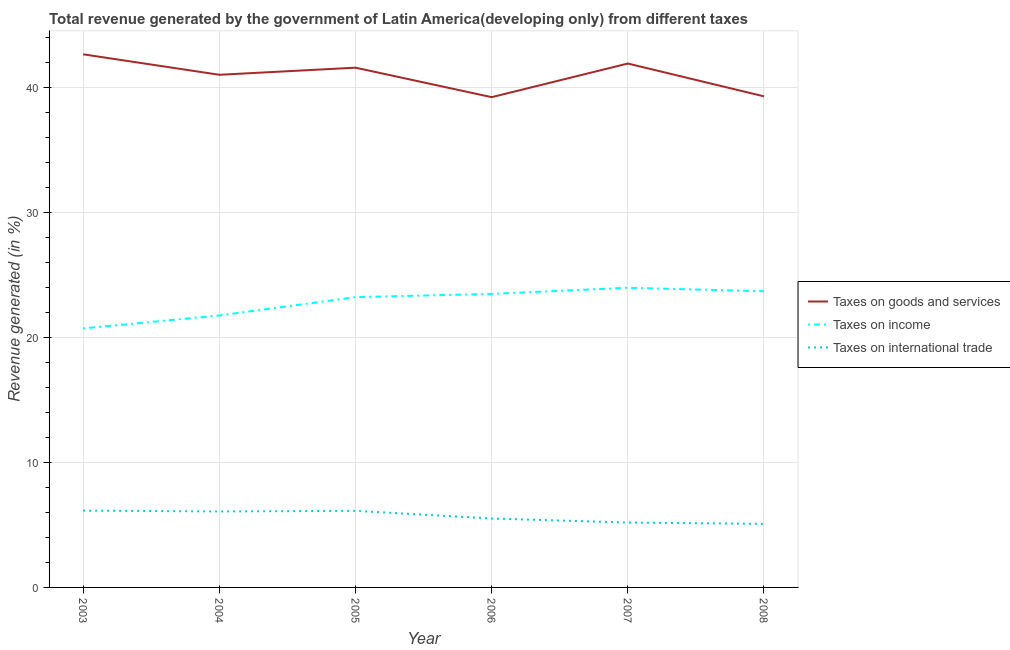How many different coloured lines are there?
Your response must be concise. 3. Does the line corresponding to percentage of revenue generated by tax on international trade intersect with the line corresponding to percentage of revenue generated by taxes on income?
Ensure brevity in your answer.  No. Is the number of lines equal to the number of legend labels?
Keep it short and to the point. Yes. What is the percentage of revenue generated by taxes on goods and services in 2004?
Make the answer very short. 40.99. Across all years, what is the maximum percentage of revenue generated by taxes on goods and services?
Offer a terse response. 42.63. Across all years, what is the minimum percentage of revenue generated by taxes on income?
Offer a terse response. 20.71. In which year was the percentage of revenue generated by taxes on income maximum?
Your response must be concise. 2007. What is the total percentage of revenue generated by tax on international trade in the graph?
Make the answer very short. 34.13. What is the difference between the percentage of revenue generated by taxes on income in 2004 and that in 2005?
Your answer should be compact. -1.46. What is the difference between the percentage of revenue generated by tax on international trade in 2008 and the percentage of revenue generated by taxes on income in 2003?
Offer a terse response. -15.63. What is the average percentage of revenue generated by taxes on income per year?
Provide a short and direct response. 22.8. In the year 2008, what is the difference between the percentage of revenue generated by tax on international trade and percentage of revenue generated by taxes on income?
Make the answer very short. -18.6. What is the ratio of the percentage of revenue generated by taxes on income in 2004 to that in 2007?
Your answer should be compact. 0.91. What is the difference between the highest and the second highest percentage of revenue generated by taxes on income?
Your response must be concise. 0.28. What is the difference between the highest and the lowest percentage of revenue generated by tax on international trade?
Keep it short and to the point. 1.06. Is the percentage of revenue generated by tax on international trade strictly less than the percentage of revenue generated by taxes on goods and services over the years?
Offer a very short reply. Yes. How many lines are there?
Provide a succinct answer. 3. How many years are there in the graph?
Your answer should be compact. 6. What is the difference between two consecutive major ticks on the Y-axis?
Keep it short and to the point. 10. Are the values on the major ticks of Y-axis written in scientific E-notation?
Give a very brief answer. No. Does the graph contain grids?
Your response must be concise. Yes. How are the legend labels stacked?
Give a very brief answer. Vertical. What is the title of the graph?
Provide a succinct answer. Total revenue generated by the government of Latin America(developing only) from different taxes. What is the label or title of the X-axis?
Provide a succinct answer. Year. What is the label or title of the Y-axis?
Offer a terse response. Revenue generated (in %). What is the Revenue generated (in %) in Taxes on goods and services in 2003?
Offer a very short reply. 42.63. What is the Revenue generated (in %) of Taxes on income in 2003?
Provide a succinct answer. 20.71. What is the Revenue generated (in %) in Taxes on international trade in 2003?
Keep it short and to the point. 6.14. What is the Revenue generated (in %) in Taxes on goods and services in 2004?
Provide a succinct answer. 40.99. What is the Revenue generated (in %) of Taxes on income in 2004?
Give a very brief answer. 21.75. What is the Revenue generated (in %) in Taxes on international trade in 2004?
Your answer should be very brief. 6.08. What is the Revenue generated (in %) of Taxes on goods and services in 2005?
Give a very brief answer. 41.56. What is the Revenue generated (in %) of Taxes on income in 2005?
Provide a short and direct response. 23.21. What is the Revenue generated (in %) of Taxes on international trade in 2005?
Make the answer very short. 6.12. What is the Revenue generated (in %) of Taxes on goods and services in 2006?
Your answer should be compact. 39.2. What is the Revenue generated (in %) of Taxes on income in 2006?
Your answer should be compact. 23.47. What is the Revenue generated (in %) in Taxes on international trade in 2006?
Your answer should be compact. 5.51. What is the Revenue generated (in %) of Taxes on goods and services in 2007?
Give a very brief answer. 41.89. What is the Revenue generated (in %) in Taxes on income in 2007?
Your answer should be compact. 23.96. What is the Revenue generated (in %) in Taxes on international trade in 2007?
Ensure brevity in your answer.  5.19. What is the Revenue generated (in %) of Taxes on goods and services in 2008?
Keep it short and to the point. 39.27. What is the Revenue generated (in %) in Taxes on income in 2008?
Your answer should be compact. 23.68. What is the Revenue generated (in %) of Taxes on international trade in 2008?
Offer a terse response. 5.08. Across all years, what is the maximum Revenue generated (in %) of Taxes on goods and services?
Offer a terse response. 42.63. Across all years, what is the maximum Revenue generated (in %) in Taxes on income?
Your answer should be very brief. 23.96. Across all years, what is the maximum Revenue generated (in %) of Taxes on international trade?
Make the answer very short. 6.14. Across all years, what is the minimum Revenue generated (in %) of Taxes on goods and services?
Keep it short and to the point. 39.2. Across all years, what is the minimum Revenue generated (in %) in Taxes on income?
Provide a short and direct response. 20.71. Across all years, what is the minimum Revenue generated (in %) of Taxes on international trade?
Keep it short and to the point. 5.08. What is the total Revenue generated (in %) in Taxes on goods and services in the graph?
Your response must be concise. 245.56. What is the total Revenue generated (in %) of Taxes on income in the graph?
Keep it short and to the point. 136.79. What is the total Revenue generated (in %) of Taxes on international trade in the graph?
Provide a succinct answer. 34.13. What is the difference between the Revenue generated (in %) in Taxes on goods and services in 2003 and that in 2004?
Give a very brief answer. 1.64. What is the difference between the Revenue generated (in %) of Taxes on income in 2003 and that in 2004?
Your response must be concise. -1.03. What is the difference between the Revenue generated (in %) in Taxes on international trade in 2003 and that in 2004?
Ensure brevity in your answer.  0.07. What is the difference between the Revenue generated (in %) of Taxes on goods and services in 2003 and that in 2005?
Offer a terse response. 1.07. What is the difference between the Revenue generated (in %) in Taxes on income in 2003 and that in 2005?
Make the answer very short. -2.5. What is the difference between the Revenue generated (in %) in Taxes on international trade in 2003 and that in 2005?
Provide a short and direct response. 0.02. What is the difference between the Revenue generated (in %) of Taxes on goods and services in 2003 and that in 2006?
Offer a terse response. 3.43. What is the difference between the Revenue generated (in %) in Taxes on income in 2003 and that in 2006?
Your answer should be compact. -2.76. What is the difference between the Revenue generated (in %) in Taxes on international trade in 2003 and that in 2006?
Offer a terse response. 0.63. What is the difference between the Revenue generated (in %) in Taxes on goods and services in 2003 and that in 2007?
Offer a terse response. 0.74. What is the difference between the Revenue generated (in %) of Taxes on income in 2003 and that in 2007?
Provide a short and direct response. -3.25. What is the difference between the Revenue generated (in %) in Taxes on international trade in 2003 and that in 2007?
Ensure brevity in your answer.  0.95. What is the difference between the Revenue generated (in %) of Taxes on goods and services in 2003 and that in 2008?
Your answer should be compact. 3.36. What is the difference between the Revenue generated (in %) in Taxes on income in 2003 and that in 2008?
Give a very brief answer. -2.97. What is the difference between the Revenue generated (in %) of Taxes on international trade in 2003 and that in 2008?
Give a very brief answer. 1.06. What is the difference between the Revenue generated (in %) of Taxes on goods and services in 2004 and that in 2005?
Your response must be concise. -0.57. What is the difference between the Revenue generated (in %) of Taxes on income in 2004 and that in 2005?
Give a very brief answer. -1.46. What is the difference between the Revenue generated (in %) of Taxes on international trade in 2004 and that in 2005?
Ensure brevity in your answer.  -0.05. What is the difference between the Revenue generated (in %) in Taxes on goods and services in 2004 and that in 2006?
Keep it short and to the point. 1.79. What is the difference between the Revenue generated (in %) of Taxes on income in 2004 and that in 2006?
Provide a succinct answer. -1.73. What is the difference between the Revenue generated (in %) of Taxes on international trade in 2004 and that in 2006?
Your answer should be compact. 0.56. What is the difference between the Revenue generated (in %) of Taxes on goods and services in 2004 and that in 2007?
Make the answer very short. -0.9. What is the difference between the Revenue generated (in %) in Taxes on income in 2004 and that in 2007?
Give a very brief answer. -2.22. What is the difference between the Revenue generated (in %) in Taxes on international trade in 2004 and that in 2007?
Ensure brevity in your answer.  0.89. What is the difference between the Revenue generated (in %) in Taxes on goods and services in 2004 and that in 2008?
Your answer should be compact. 1.72. What is the difference between the Revenue generated (in %) of Taxes on income in 2004 and that in 2008?
Provide a succinct answer. -1.94. What is the difference between the Revenue generated (in %) in Taxes on international trade in 2004 and that in 2008?
Make the answer very short. 0.99. What is the difference between the Revenue generated (in %) of Taxes on goods and services in 2005 and that in 2006?
Ensure brevity in your answer.  2.36. What is the difference between the Revenue generated (in %) in Taxes on income in 2005 and that in 2006?
Ensure brevity in your answer.  -0.26. What is the difference between the Revenue generated (in %) in Taxes on international trade in 2005 and that in 2006?
Provide a succinct answer. 0.61. What is the difference between the Revenue generated (in %) in Taxes on goods and services in 2005 and that in 2007?
Offer a very short reply. -0.33. What is the difference between the Revenue generated (in %) in Taxes on income in 2005 and that in 2007?
Your answer should be very brief. -0.75. What is the difference between the Revenue generated (in %) of Taxes on international trade in 2005 and that in 2007?
Provide a succinct answer. 0.94. What is the difference between the Revenue generated (in %) of Taxes on goods and services in 2005 and that in 2008?
Keep it short and to the point. 2.29. What is the difference between the Revenue generated (in %) in Taxes on income in 2005 and that in 2008?
Make the answer very short. -0.47. What is the difference between the Revenue generated (in %) in Taxes on international trade in 2005 and that in 2008?
Your response must be concise. 1.04. What is the difference between the Revenue generated (in %) in Taxes on goods and services in 2006 and that in 2007?
Offer a very short reply. -2.69. What is the difference between the Revenue generated (in %) in Taxes on income in 2006 and that in 2007?
Your answer should be very brief. -0.49. What is the difference between the Revenue generated (in %) in Taxes on international trade in 2006 and that in 2007?
Make the answer very short. 0.32. What is the difference between the Revenue generated (in %) in Taxes on goods and services in 2006 and that in 2008?
Keep it short and to the point. -0.07. What is the difference between the Revenue generated (in %) in Taxes on income in 2006 and that in 2008?
Provide a succinct answer. -0.21. What is the difference between the Revenue generated (in %) of Taxes on international trade in 2006 and that in 2008?
Keep it short and to the point. 0.43. What is the difference between the Revenue generated (in %) in Taxes on goods and services in 2007 and that in 2008?
Your response must be concise. 2.62. What is the difference between the Revenue generated (in %) in Taxes on income in 2007 and that in 2008?
Offer a very short reply. 0.28. What is the difference between the Revenue generated (in %) in Taxes on international trade in 2007 and that in 2008?
Give a very brief answer. 0.11. What is the difference between the Revenue generated (in %) in Taxes on goods and services in 2003 and the Revenue generated (in %) in Taxes on income in 2004?
Keep it short and to the point. 20.89. What is the difference between the Revenue generated (in %) in Taxes on goods and services in 2003 and the Revenue generated (in %) in Taxes on international trade in 2004?
Your answer should be compact. 36.56. What is the difference between the Revenue generated (in %) in Taxes on income in 2003 and the Revenue generated (in %) in Taxes on international trade in 2004?
Keep it short and to the point. 14.64. What is the difference between the Revenue generated (in %) of Taxes on goods and services in 2003 and the Revenue generated (in %) of Taxes on income in 2005?
Give a very brief answer. 19.42. What is the difference between the Revenue generated (in %) in Taxes on goods and services in 2003 and the Revenue generated (in %) in Taxes on international trade in 2005?
Offer a terse response. 36.51. What is the difference between the Revenue generated (in %) of Taxes on income in 2003 and the Revenue generated (in %) of Taxes on international trade in 2005?
Provide a short and direct response. 14.59. What is the difference between the Revenue generated (in %) of Taxes on goods and services in 2003 and the Revenue generated (in %) of Taxes on income in 2006?
Make the answer very short. 19.16. What is the difference between the Revenue generated (in %) of Taxes on goods and services in 2003 and the Revenue generated (in %) of Taxes on international trade in 2006?
Your answer should be compact. 37.12. What is the difference between the Revenue generated (in %) in Taxes on income in 2003 and the Revenue generated (in %) in Taxes on international trade in 2006?
Provide a succinct answer. 15.2. What is the difference between the Revenue generated (in %) of Taxes on goods and services in 2003 and the Revenue generated (in %) of Taxes on income in 2007?
Your answer should be very brief. 18.67. What is the difference between the Revenue generated (in %) of Taxes on goods and services in 2003 and the Revenue generated (in %) of Taxes on international trade in 2007?
Provide a succinct answer. 37.44. What is the difference between the Revenue generated (in %) of Taxes on income in 2003 and the Revenue generated (in %) of Taxes on international trade in 2007?
Make the answer very short. 15.52. What is the difference between the Revenue generated (in %) of Taxes on goods and services in 2003 and the Revenue generated (in %) of Taxes on income in 2008?
Offer a very short reply. 18.95. What is the difference between the Revenue generated (in %) in Taxes on goods and services in 2003 and the Revenue generated (in %) in Taxes on international trade in 2008?
Ensure brevity in your answer.  37.55. What is the difference between the Revenue generated (in %) in Taxes on income in 2003 and the Revenue generated (in %) in Taxes on international trade in 2008?
Ensure brevity in your answer.  15.63. What is the difference between the Revenue generated (in %) of Taxes on goods and services in 2004 and the Revenue generated (in %) of Taxes on income in 2005?
Your answer should be compact. 17.78. What is the difference between the Revenue generated (in %) of Taxes on goods and services in 2004 and the Revenue generated (in %) of Taxes on international trade in 2005?
Your response must be concise. 34.87. What is the difference between the Revenue generated (in %) of Taxes on income in 2004 and the Revenue generated (in %) of Taxes on international trade in 2005?
Make the answer very short. 15.62. What is the difference between the Revenue generated (in %) of Taxes on goods and services in 2004 and the Revenue generated (in %) of Taxes on income in 2006?
Keep it short and to the point. 17.52. What is the difference between the Revenue generated (in %) in Taxes on goods and services in 2004 and the Revenue generated (in %) in Taxes on international trade in 2006?
Your response must be concise. 35.48. What is the difference between the Revenue generated (in %) in Taxes on income in 2004 and the Revenue generated (in %) in Taxes on international trade in 2006?
Keep it short and to the point. 16.23. What is the difference between the Revenue generated (in %) in Taxes on goods and services in 2004 and the Revenue generated (in %) in Taxes on income in 2007?
Your answer should be very brief. 17.03. What is the difference between the Revenue generated (in %) in Taxes on goods and services in 2004 and the Revenue generated (in %) in Taxes on international trade in 2007?
Your response must be concise. 35.81. What is the difference between the Revenue generated (in %) of Taxes on income in 2004 and the Revenue generated (in %) of Taxes on international trade in 2007?
Make the answer very short. 16.56. What is the difference between the Revenue generated (in %) in Taxes on goods and services in 2004 and the Revenue generated (in %) in Taxes on income in 2008?
Provide a short and direct response. 17.31. What is the difference between the Revenue generated (in %) in Taxes on goods and services in 2004 and the Revenue generated (in %) in Taxes on international trade in 2008?
Offer a terse response. 35.91. What is the difference between the Revenue generated (in %) in Taxes on income in 2004 and the Revenue generated (in %) in Taxes on international trade in 2008?
Provide a succinct answer. 16.67. What is the difference between the Revenue generated (in %) of Taxes on goods and services in 2005 and the Revenue generated (in %) of Taxes on income in 2006?
Make the answer very short. 18.09. What is the difference between the Revenue generated (in %) in Taxes on goods and services in 2005 and the Revenue generated (in %) in Taxes on international trade in 2006?
Ensure brevity in your answer.  36.05. What is the difference between the Revenue generated (in %) in Taxes on income in 2005 and the Revenue generated (in %) in Taxes on international trade in 2006?
Your answer should be very brief. 17.7. What is the difference between the Revenue generated (in %) in Taxes on goods and services in 2005 and the Revenue generated (in %) in Taxes on income in 2007?
Make the answer very short. 17.6. What is the difference between the Revenue generated (in %) of Taxes on goods and services in 2005 and the Revenue generated (in %) of Taxes on international trade in 2007?
Make the answer very short. 36.37. What is the difference between the Revenue generated (in %) of Taxes on income in 2005 and the Revenue generated (in %) of Taxes on international trade in 2007?
Ensure brevity in your answer.  18.02. What is the difference between the Revenue generated (in %) of Taxes on goods and services in 2005 and the Revenue generated (in %) of Taxes on income in 2008?
Your answer should be very brief. 17.88. What is the difference between the Revenue generated (in %) of Taxes on goods and services in 2005 and the Revenue generated (in %) of Taxes on international trade in 2008?
Provide a short and direct response. 36.48. What is the difference between the Revenue generated (in %) of Taxes on income in 2005 and the Revenue generated (in %) of Taxes on international trade in 2008?
Make the answer very short. 18.13. What is the difference between the Revenue generated (in %) in Taxes on goods and services in 2006 and the Revenue generated (in %) in Taxes on income in 2007?
Give a very brief answer. 15.24. What is the difference between the Revenue generated (in %) of Taxes on goods and services in 2006 and the Revenue generated (in %) of Taxes on international trade in 2007?
Provide a succinct answer. 34.02. What is the difference between the Revenue generated (in %) of Taxes on income in 2006 and the Revenue generated (in %) of Taxes on international trade in 2007?
Offer a very short reply. 18.29. What is the difference between the Revenue generated (in %) in Taxes on goods and services in 2006 and the Revenue generated (in %) in Taxes on income in 2008?
Give a very brief answer. 15.52. What is the difference between the Revenue generated (in %) in Taxes on goods and services in 2006 and the Revenue generated (in %) in Taxes on international trade in 2008?
Provide a short and direct response. 34.12. What is the difference between the Revenue generated (in %) in Taxes on income in 2006 and the Revenue generated (in %) in Taxes on international trade in 2008?
Give a very brief answer. 18.39. What is the difference between the Revenue generated (in %) of Taxes on goods and services in 2007 and the Revenue generated (in %) of Taxes on income in 2008?
Make the answer very short. 18.21. What is the difference between the Revenue generated (in %) in Taxes on goods and services in 2007 and the Revenue generated (in %) in Taxes on international trade in 2008?
Your answer should be very brief. 36.81. What is the difference between the Revenue generated (in %) in Taxes on income in 2007 and the Revenue generated (in %) in Taxes on international trade in 2008?
Offer a terse response. 18.88. What is the average Revenue generated (in %) of Taxes on goods and services per year?
Your response must be concise. 40.93. What is the average Revenue generated (in %) of Taxes on income per year?
Provide a short and direct response. 22.8. What is the average Revenue generated (in %) in Taxes on international trade per year?
Give a very brief answer. 5.69. In the year 2003, what is the difference between the Revenue generated (in %) in Taxes on goods and services and Revenue generated (in %) in Taxes on income?
Keep it short and to the point. 21.92. In the year 2003, what is the difference between the Revenue generated (in %) in Taxes on goods and services and Revenue generated (in %) in Taxes on international trade?
Keep it short and to the point. 36.49. In the year 2003, what is the difference between the Revenue generated (in %) in Taxes on income and Revenue generated (in %) in Taxes on international trade?
Keep it short and to the point. 14.57. In the year 2004, what is the difference between the Revenue generated (in %) of Taxes on goods and services and Revenue generated (in %) of Taxes on income?
Offer a very short reply. 19.25. In the year 2004, what is the difference between the Revenue generated (in %) of Taxes on goods and services and Revenue generated (in %) of Taxes on international trade?
Provide a short and direct response. 34.92. In the year 2004, what is the difference between the Revenue generated (in %) of Taxes on income and Revenue generated (in %) of Taxes on international trade?
Your response must be concise. 15.67. In the year 2005, what is the difference between the Revenue generated (in %) of Taxes on goods and services and Revenue generated (in %) of Taxes on income?
Provide a succinct answer. 18.35. In the year 2005, what is the difference between the Revenue generated (in %) in Taxes on goods and services and Revenue generated (in %) in Taxes on international trade?
Keep it short and to the point. 35.44. In the year 2005, what is the difference between the Revenue generated (in %) in Taxes on income and Revenue generated (in %) in Taxes on international trade?
Give a very brief answer. 17.09. In the year 2006, what is the difference between the Revenue generated (in %) of Taxes on goods and services and Revenue generated (in %) of Taxes on income?
Offer a very short reply. 15.73. In the year 2006, what is the difference between the Revenue generated (in %) of Taxes on goods and services and Revenue generated (in %) of Taxes on international trade?
Provide a short and direct response. 33.69. In the year 2006, what is the difference between the Revenue generated (in %) of Taxes on income and Revenue generated (in %) of Taxes on international trade?
Ensure brevity in your answer.  17.96. In the year 2007, what is the difference between the Revenue generated (in %) in Taxes on goods and services and Revenue generated (in %) in Taxes on income?
Offer a terse response. 17.93. In the year 2007, what is the difference between the Revenue generated (in %) of Taxes on goods and services and Revenue generated (in %) of Taxes on international trade?
Your answer should be very brief. 36.71. In the year 2007, what is the difference between the Revenue generated (in %) of Taxes on income and Revenue generated (in %) of Taxes on international trade?
Give a very brief answer. 18.77. In the year 2008, what is the difference between the Revenue generated (in %) in Taxes on goods and services and Revenue generated (in %) in Taxes on income?
Your answer should be compact. 15.59. In the year 2008, what is the difference between the Revenue generated (in %) of Taxes on goods and services and Revenue generated (in %) of Taxes on international trade?
Provide a succinct answer. 34.19. In the year 2008, what is the difference between the Revenue generated (in %) of Taxes on income and Revenue generated (in %) of Taxes on international trade?
Give a very brief answer. 18.6. What is the ratio of the Revenue generated (in %) of Taxes on goods and services in 2003 to that in 2004?
Your answer should be very brief. 1.04. What is the ratio of the Revenue generated (in %) in Taxes on income in 2003 to that in 2004?
Ensure brevity in your answer.  0.95. What is the ratio of the Revenue generated (in %) of Taxes on international trade in 2003 to that in 2004?
Your answer should be compact. 1.01. What is the ratio of the Revenue generated (in %) in Taxes on goods and services in 2003 to that in 2005?
Provide a succinct answer. 1.03. What is the ratio of the Revenue generated (in %) in Taxes on income in 2003 to that in 2005?
Your answer should be compact. 0.89. What is the ratio of the Revenue generated (in %) of Taxes on international trade in 2003 to that in 2005?
Keep it short and to the point. 1. What is the ratio of the Revenue generated (in %) of Taxes on goods and services in 2003 to that in 2006?
Make the answer very short. 1.09. What is the ratio of the Revenue generated (in %) in Taxes on income in 2003 to that in 2006?
Offer a very short reply. 0.88. What is the ratio of the Revenue generated (in %) in Taxes on international trade in 2003 to that in 2006?
Keep it short and to the point. 1.11. What is the ratio of the Revenue generated (in %) in Taxes on goods and services in 2003 to that in 2007?
Make the answer very short. 1.02. What is the ratio of the Revenue generated (in %) of Taxes on income in 2003 to that in 2007?
Your answer should be very brief. 0.86. What is the ratio of the Revenue generated (in %) in Taxes on international trade in 2003 to that in 2007?
Your answer should be compact. 1.18. What is the ratio of the Revenue generated (in %) in Taxes on goods and services in 2003 to that in 2008?
Make the answer very short. 1.09. What is the ratio of the Revenue generated (in %) in Taxes on income in 2003 to that in 2008?
Keep it short and to the point. 0.87. What is the ratio of the Revenue generated (in %) in Taxes on international trade in 2003 to that in 2008?
Ensure brevity in your answer.  1.21. What is the ratio of the Revenue generated (in %) in Taxes on goods and services in 2004 to that in 2005?
Make the answer very short. 0.99. What is the ratio of the Revenue generated (in %) in Taxes on income in 2004 to that in 2005?
Offer a very short reply. 0.94. What is the ratio of the Revenue generated (in %) of Taxes on goods and services in 2004 to that in 2006?
Keep it short and to the point. 1.05. What is the ratio of the Revenue generated (in %) in Taxes on income in 2004 to that in 2006?
Your response must be concise. 0.93. What is the ratio of the Revenue generated (in %) of Taxes on international trade in 2004 to that in 2006?
Offer a very short reply. 1.1. What is the ratio of the Revenue generated (in %) of Taxes on goods and services in 2004 to that in 2007?
Provide a succinct answer. 0.98. What is the ratio of the Revenue generated (in %) of Taxes on income in 2004 to that in 2007?
Ensure brevity in your answer.  0.91. What is the ratio of the Revenue generated (in %) of Taxes on international trade in 2004 to that in 2007?
Provide a short and direct response. 1.17. What is the ratio of the Revenue generated (in %) in Taxes on goods and services in 2004 to that in 2008?
Provide a succinct answer. 1.04. What is the ratio of the Revenue generated (in %) of Taxes on income in 2004 to that in 2008?
Make the answer very short. 0.92. What is the ratio of the Revenue generated (in %) of Taxes on international trade in 2004 to that in 2008?
Keep it short and to the point. 1.2. What is the ratio of the Revenue generated (in %) in Taxes on goods and services in 2005 to that in 2006?
Your answer should be compact. 1.06. What is the ratio of the Revenue generated (in %) in Taxes on income in 2005 to that in 2006?
Offer a terse response. 0.99. What is the ratio of the Revenue generated (in %) in Taxes on income in 2005 to that in 2007?
Your answer should be compact. 0.97. What is the ratio of the Revenue generated (in %) of Taxes on international trade in 2005 to that in 2007?
Your answer should be compact. 1.18. What is the ratio of the Revenue generated (in %) in Taxes on goods and services in 2005 to that in 2008?
Give a very brief answer. 1.06. What is the ratio of the Revenue generated (in %) of Taxes on income in 2005 to that in 2008?
Provide a succinct answer. 0.98. What is the ratio of the Revenue generated (in %) in Taxes on international trade in 2005 to that in 2008?
Ensure brevity in your answer.  1.21. What is the ratio of the Revenue generated (in %) in Taxes on goods and services in 2006 to that in 2007?
Your response must be concise. 0.94. What is the ratio of the Revenue generated (in %) of Taxes on income in 2006 to that in 2007?
Your answer should be compact. 0.98. What is the ratio of the Revenue generated (in %) of Taxes on international trade in 2006 to that in 2007?
Your answer should be compact. 1.06. What is the ratio of the Revenue generated (in %) of Taxes on goods and services in 2006 to that in 2008?
Provide a short and direct response. 1. What is the ratio of the Revenue generated (in %) of Taxes on income in 2006 to that in 2008?
Your answer should be compact. 0.99. What is the ratio of the Revenue generated (in %) in Taxes on international trade in 2006 to that in 2008?
Your response must be concise. 1.08. What is the ratio of the Revenue generated (in %) in Taxes on goods and services in 2007 to that in 2008?
Keep it short and to the point. 1.07. What is the ratio of the Revenue generated (in %) of Taxes on income in 2007 to that in 2008?
Make the answer very short. 1.01. What is the ratio of the Revenue generated (in %) in Taxes on international trade in 2007 to that in 2008?
Provide a short and direct response. 1.02. What is the difference between the highest and the second highest Revenue generated (in %) in Taxes on goods and services?
Give a very brief answer. 0.74. What is the difference between the highest and the second highest Revenue generated (in %) of Taxes on income?
Make the answer very short. 0.28. What is the difference between the highest and the second highest Revenue generated (in %) in Taxes on international trade?
Offer a very short reply. 0.02. What is the difference between the highest and the lowest Revenue generated (in %) in Taxes on goods and services?
Offer a terse response. 3.43. What is the difference between the highest and the lowest Revenue generated (in %) of Taxes on income?
Your answer should be compact. 3.25. What is the difference between the highest and the lowest Revenue generated (in %) in Taxes on international trade?
Make the answer very short. 1.06. 